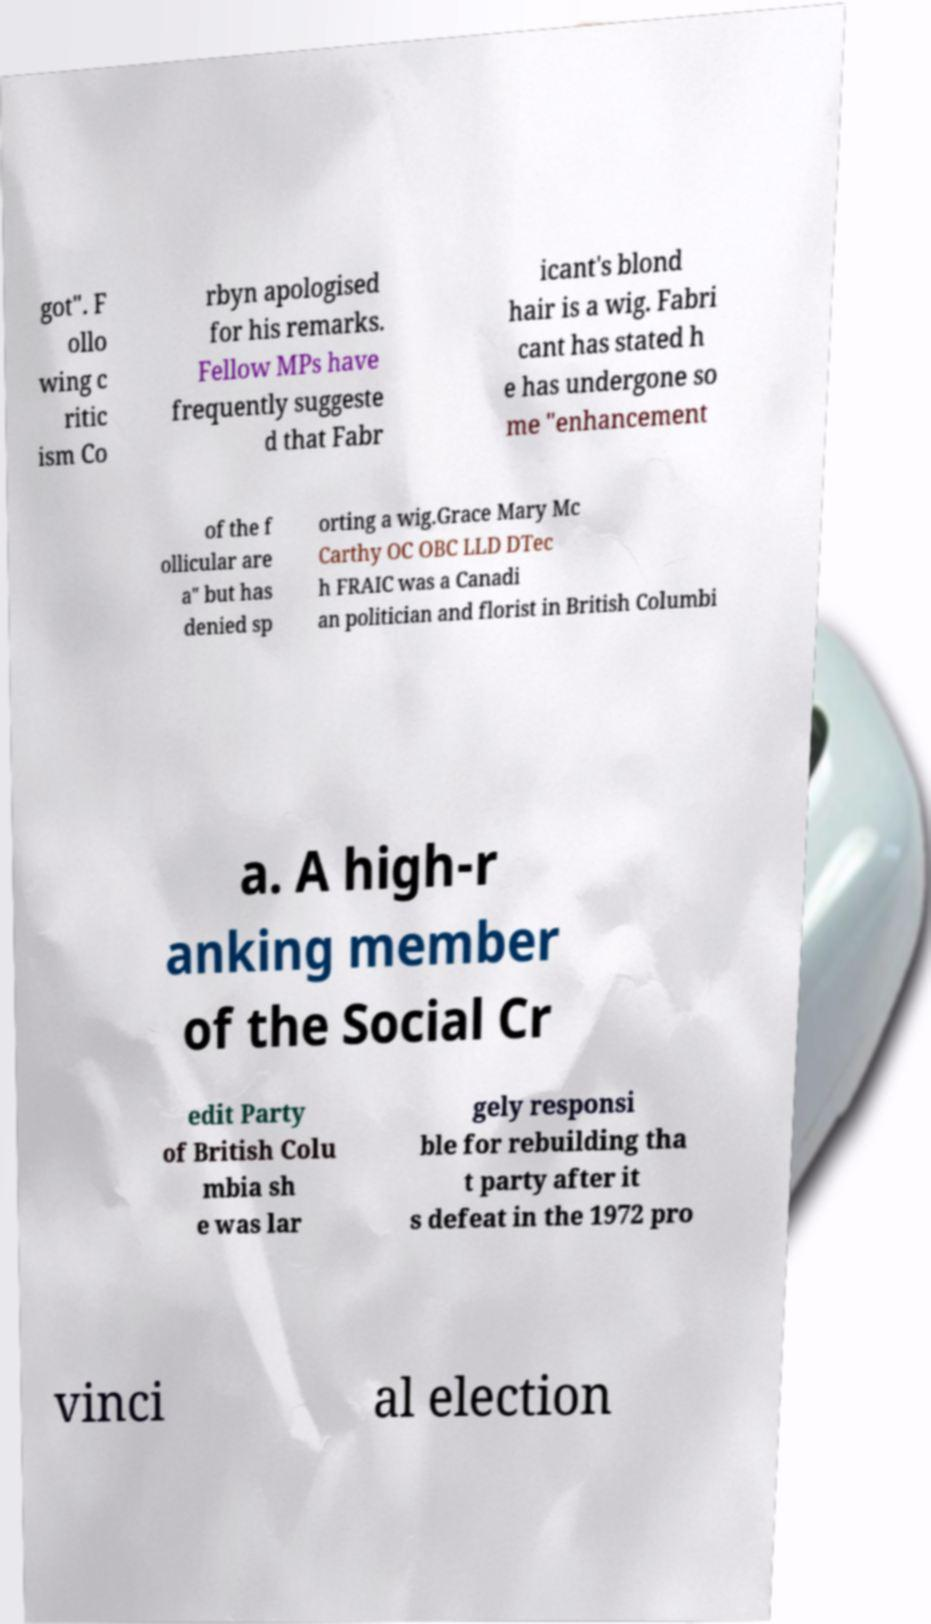I need the written content from this picture converted into text. Can you do that? got". F ollo wing c ritic ism Co rbyn apologised for his remarks. Fellow MPs have frequently suggeste d that Fabr icant's blond hair is a wig. Fabri cant has stated h e has undergone so me "enhancement of the f ollicular are a" but has denied sp orting a wig.Grace Mary Mc Carthy OC OBC LLD DTec h FRAIC was a Canadi an politician and florist in British Columbi a. A high-r anking member of the Social Cr edit Party of British Colu mbia sh e was lar gely responsi ble for rebuilding tha t party after it s defeat in the 1972 pro vinci al election 